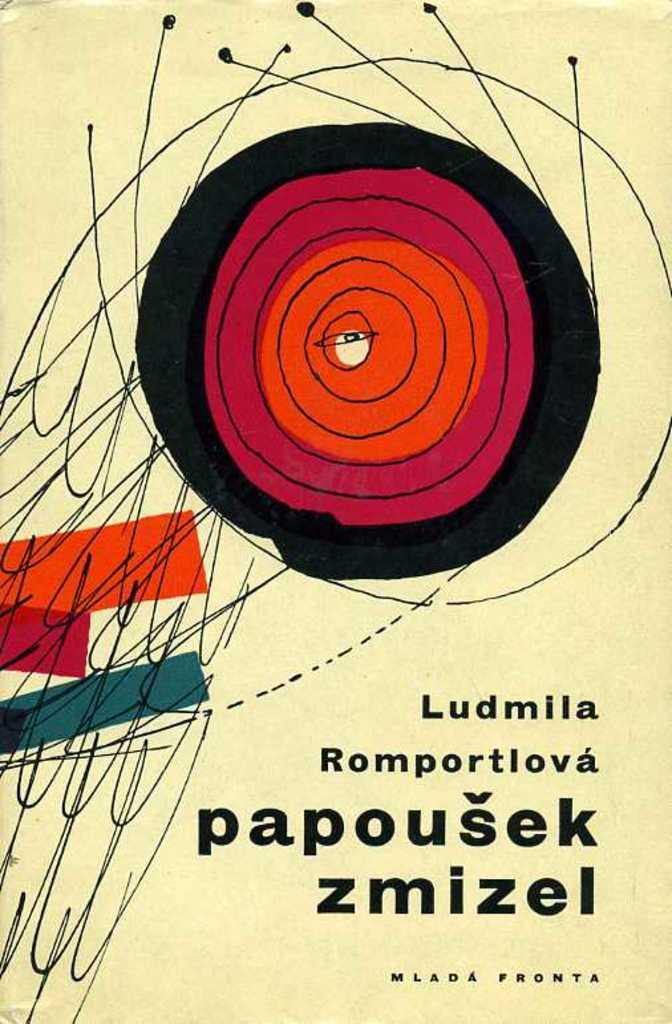<image>
Describe the image concisely. A book that is titled Papousek zmizel in another language. 